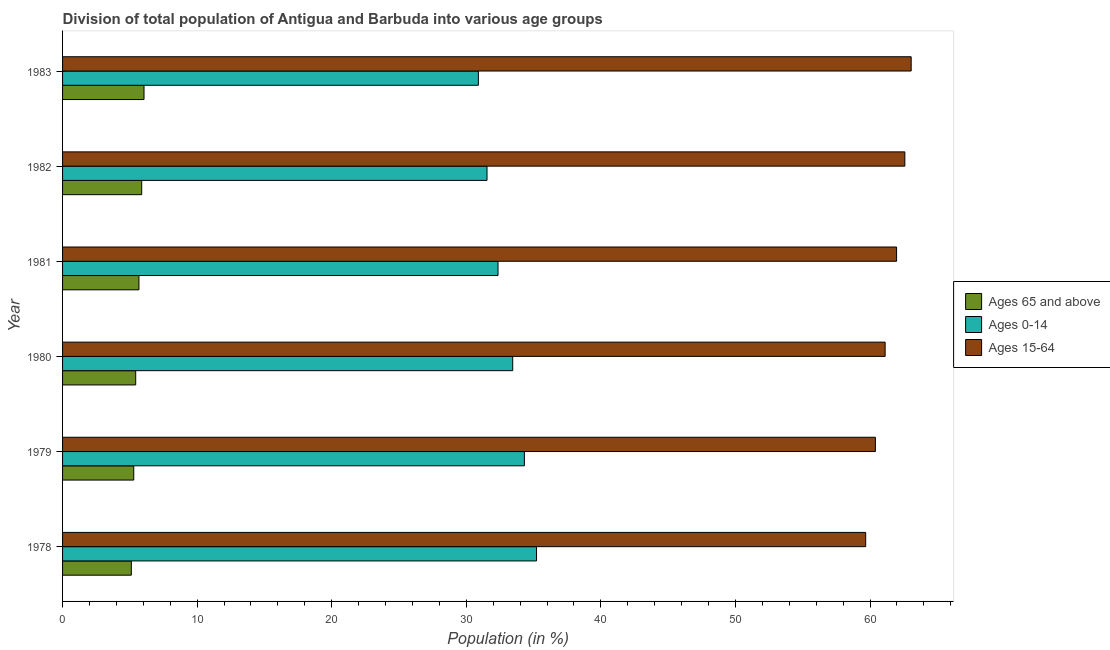How many groups of bars are there?
Provide a succinct answer. 6. Are the number of bars per tick equal to the number of legend labels?
Your response must be concise. Yes. How many bars are there on the 4th tick from the top?
Provide a short and direct response. 3. What is the label of the 1st group of bars from the top?
Keep it short and to the point. 1983. What is the percentage of population within the age-group of 65 and above in 1980?
Offer a very short reply. 5.43. Across all years, what is the maximum percentage of population within the age-group 0-14?
Your answer should be compact. 35.22. Across all years, what is the minimum percentage of population within the age-group of 65 and above?
Your response must be concise. 5.11. In which year was the percentage of population within the age-group 0-14 maximum?
Give a very brief answer. 1978. In which year was the percentage of population within the age-group of 65 and above minimum?
Provide a short and direct response. 1978. What is the total percentage of population within the age-group 0-14 in the graph?
Make the answer very short. 197.77. What is the difference between the percentage of population within the age-group 0-14 in 1979 and that in 1983?
Your answer should be compact. 3.42. What is the difference between the percentage of population within the age-group of 65 and above in 1983 and the percentage of population within the age-group 15-64 in 1982?
Offer a terse response. -56.53. What is the average percentage of population within the age-group 15-64 per year?
Keep it short and to the point. 61.47. In the year 1978, what is the difference between the percentage of population within the age-group 15-64 and percentage of population within the age-group of 65 and above?
Offer a terse response. 54.56. What is the ratio of the percentage of population within the age-group of 65 and above in 1978 to that in 1979?
Provide a succinct answer. 0.97. Is the percentage of population within the age-group of 65 and above in 1980 less than that in 1981?
Ensure brevity in your answer.  Yes. Is the difference between the percentage of population within the age-group 0-14 in 1978 and 1979 greater than the difference between the percentage of population within the age-group 15-64 in 1978 and 1979?
Provide a short and direct response. Yes. What is the difference between the highest and the second highest percentage of population within the age-group 0-14?
Provide a short and direct response. 0.9. What is the difference between the highest and the lowest percentage of population within the age-group 0-14?
Your answer should be compact. 4.32. In how many years, is the percentage of population within the age-group of 65 and above greater than the average percentage of population within the age-group of 65 and above taken over all years?
Provide a succinct answer. 3. What does the 3rd bar from the top in 1982 represents?
Provide a succinct answer. Ages 65 and above. What does the 3rd bar from the bottom in 1978 represents?
Your answer should be compact. Ages 15-64. Is it the case that in every year, the sum of the percentage of population within the age-group of 65 and above and percentage of population within the age-group 0-14 is greater than the percentage of population within the age-group 15-64?
Your response must be concise. No. How many bars are there?
Keep it short and to the point. 18. Are all the bars in the graph horizontal?
Provide a short and direct response. Yes. What is the difference between two consecutive major ticks on the X-axis?
Your answer should be very brief. 10. Are the values on the major ticks of X-axis written in scientific E-notation?
Offer a very short reply. No. Does the graph contain grids?
Keep it short and to the point. No. Where does the legend appear in the graph?
Provide a short and direct response. Center right. How many legend labels are there?
Your answer should be very brief. 3. How are the legend labels stacked?
Your answer should be compact. Vertical. What is the title of the graph?
Ensure brevity in your answer.  Division of total population of Antigua and Barbuda into various age groups
. What is the Population (in %) in Ages 65 and above in 1978?
Offer a terse response. 5.11. What is the Population (in %) in Ages 0-14 in 1978?
Provide a succinct answer. 35.22. What is the Population (in %) in Ages 15-64 in 1978?
Give a very brief answer. 59.67. What is the Population (in %) of Ages 65 and above in 1979?
Ensure brevity in your answer.  5.29. What is the Population (in %) in Ages 0-14 in 1979?
Provide a short and direct response. 34.31. What is the Population (in %) of Ages 15-64 in 1979?
Provide a succinct answer. 60.4. What is the Population (in %) of Ages 65 and above in 1980?
Make the answer very short. 5.43. What is the Population (in %) of Ages 0-14 in 1980?
Provide a short and direct response. 33.45. What is the Population (in %) in Ages 15-64 in 1980?
Offer a very short reply. 61.12. What is the Population (in %) of Ages 65 and above in 1981?
Offer a very short reply. 5.67. What is the Population (in %) in Ages 0-14 in 1981?
Your response must be concise. 32.36. What is the Population (in %) in Ages 15-64 in 1981?
Make the answer very short. 61.97. What is the Population (in %) in Ages 65 and above in 1982?
Your answer should be compact. 5.88. What is the Population (in %) in Ages 0-14 in 1982?
Make the answer very short. 31.54. What is the Population (in %) of Ages 15-64 in 1982?
Ensure brevity in your answer.  62.58. What is the Population (in %) in Ages 65 and above in 1983?
Offer a very short reply. 6.05. What is the Population (in %) in Ages 0-14 in 1983?
Make the answer very short. 30.89. What is the Population (in %) of Ages 15-64 in 1983?
Make the answer very short. 63.05. Across all years, what is the maximum Population (in %) in Ages 65 and above?
Your answer should be very brief. 6.05. Across all years, what is the maximum Population (in %) in Ages 0-14?
Your response must be concise. 35.22. Across all years, what is the maximum Population (in %) in Ages 15-64?
Make the answer very short. 63.05. Across all years, what is the minimum Population (in %) in Ages 65 and above?
Your answer should be very brief. 5.11. Across all years, what is the minimum Population (in %) of Ages 0-14?
Make the answer very short. 30.89. Across all years, what is the minimum Population (in %) of Ages 15-64?
Your response must be concise. 59.67. What is the total Population (in %) in Ages 65 and above in the graph?
Ensure brevity in your answer.  33.44. What is the total Population (in %) in Ages 0-14 in the graph?
Your answer should be compact. 197.77. What is the total Population (in %) in Ages 15-64 in the graph?
Offer a terse response. 368.8. What is the difference between the Population (in %) of Ages 65 and above in 1978 and that in 1979?
Ensure brevity in your answer.  -0.18. What is the difference between the Population (in %) in Ages 0-14 in 1978 and that in 1979?
Make the answer very short. 0.9. What is the difference between the Population (in %) of Ages 15-64 in 1978 and that in 1979?
Your answer should be very brief. -0.72. What is the difference between the Population (in %) in Ages 65 and above in 1978 and that in 1980?
Offer a very short reply. -0.33. What is the difference between the Population (in %) of Ages 0-14 in 1978 and that in 1980?
Ensure brevity in your answer.  1.77. What is the difference between the Population (in %) of Ages 15-64 in 1978 and that in 1980?
Keep it short and to the point. -1.44. What is the difference between the Population (in %) in Ages 65 and above in 1978 and that in 1981?
Your answer should be compact. -0.57. What is the difference between the Population (in %) in Ages 0-14 in 1978 and that in 1981?
Your answer should be compact. 2.86. What is the difference between the Population (in %) in Ages 15-64 in 1978 and that in 1981?
Provide a short and direct response. -2.3. What is the difference between the Population (in %) of Ages 65 and above in 1978 and that in 1982?
Make the answer very short. -0.77. What is the difference between the Population (in %) of Ages 0-14 in 1978 and that in 1982?
Keep it short and to the point. 3.68. What is the difference between the Population (in %) of Ages 15-64 in 1978 and that in 1982?
Your answer should be very brief. -2.91. What is the difference between the Population (in %) of Ages 65 and above in 1978 and that in 1983?
Offer a terse response. -0.94. What is the difference between the Population (in %) in Ages 0-14 in 1978 and that in 1983?
Your answer should be compact. 4.32. What is the difference between the Population (in %) in Ages 15-64 in 1978 and that in 1983?
Make the answer very short. -3.38. What is the difference between the Population (in %) of Ages 65 and above in 1979 and that in 1980?
Offer a terse response. -0.14. What is the difference between the Population (in %) in Ages 0-14 in 1979 and that in 1980?
Ensure brevity in your answer.  0.87. What is the difference between the Population (in %) of Ages 15-64 in 1979 and that in 1980?
Offer a very short reply. -0.72. What is the difference between the Population (in %) of Ages 65 and above in 1979 and that in 1981?
Make the answer very short. -0.38. What is the difference between the Population (in %) in Ages 0-14 in 1979 and that in 1981?
Your answer should be compact. 1.96. What is the difference between the Population (in %) in Ages 15-64 in 1979 and that in 1981?
Your response must be concise. -1.57. What is the difference between the Population (in %) in Ages 65 and above in 1979 and that in 1982?
Your answer should be compact. -0.59. What is the difference between the Population (in %) in Ages 0-14 in 1979 and that in 1982?
Offer a terse response. 2.78. What is the difference between the Population (in %) in Ages 15-64 in 1979 and that in 1982?
Give a very brief answer. -2.19. What is the difference between the Population (in %) of Ages 65 and above in 1979 and that in 1983?
Offer a terse response. -0.76. What is the difference between the Population (in %) in Ages 0-14 in 1979 and that in 1983?
Provide a short and direct response. 3.42. What is the difference between the Population (in %) of Ages 15-64 in 1979 and that in 1983?
Your answer should be very brief. -2.66. What is the difference between the Population (in %) in Ages 65 and above in 1980 and that in 1981?
Your response must be concise. -0.24. What is the difference between the Population (in %) of Ages 0-14 in 1980 and that in 1981?
Your answer should be compact. 1.09. What is the difference between the Population (in %) in Ages 15-64 in 1980 and that in 1981?
Your answer should be very brief. -0.85. What is the difference between the Population (in %) in Ages 65 and above in 1980 and that in 1982?
Your answer should be very brief. -0.45. What is the difference between the Population (in %) in Ages 0-14 in 1980 and that in 1982?
Make the answer very short. 1.91. What is the difference between the Population (in %) in Ages 15-64 in 1980 and that in 1982?
Provide a short and direct response. -1.46. What is the difference between the Population (in %) of Ages 65 and above in 1980 and that in 1983?
Your answer should be compact. -0.62. What is the difference between the Population (in %) of Ages 0-14 in 1980 and that in 1983?
Your response must be concise. 2.55. What is the difference between the Population (in %) in Ages 15-64 in 1980 and that in 1983?
Provide a short and direct response. -1.94. What is the difference between the Population (in %) in Ages 65 and above in 1981 and that in 1982?
Your answer should be compact. -0.21. What is the difference between the Population (in %) in Ages 0-14 in 1981 and that in 1982?
Offer a terse response. 0.82. What is the difference between the Population (in %) in Ages 15-64 in 1981 and that in 1982?
Provide a short and direct response. -0.61. What is the difference between the Population (in %) of Ages 65 and above in 1981 and that in 1983?
Keep it short and to the point. -0.38. What is the difference between the Population (in %) in Ages 0-14 in 1981 and that in 1983?
Offer a very short reply. 1.46. What is the difference between the Population (in %) in Ages 15-64 in 1981 and that in 1983?
Your answer should be very brief. -1.08. What is the difference between the Population (in %) of Ages 65 and above in 1982 and that in 1983?
Offer a very short reply. -0.17. What is the difference between the Population (in %) of Ages 0-14 in 1982 and that in 1983?
Your response must be concise. 0.64. What is the difference between the Population (in %) of Ages 15-64 in 1982 and that in 1983?
Your response must be concise. -0.47. What is the difference between the Population (in %) in Ages 65 and above in 1978 and the Population (in %) in Ages 0-14 in 1979?
Provide a succinct answer. -29.21. What is the difference between the Population (in %) in Ages 65 and above in 1978 and the Population (in %) in Ages 15-64 in 1979?
Offer a very short reply. -55.29. What is the difference between the Population (in %) of Ages 0-14 in 1978 and the Population (in %) of Ages 15-64 in 1979?
Give a very brief answer. -25.18. What is the difference between the Population (in %) of Ages 65 and above in 1978 and the Population (in %) of Ages 0-14 in 1980?
Give a very brief answer. -28.34. What is the difference between the Population (in %) of Ages 65 and above in 1978 and the Population (in %) of Ages 15-64 in 1980?
Ensure brevity in your answer.  -56.01. What is the difference between the Population (in %) of Ages 0-14 in 1978 and the Population (in %) of Ages 15-64 in 1980?
Provide a short and direct response. -25.9. What is the difference between the Population (in %) of Ages 65 and above in 1978 and the Population (in %) of Ages 0-14 in 1981?
Provide a succinct answer. -27.25. What is the difference between the Population (in %) in Ages 65 and above in 1978 and the Population (in %) in Ages 15-64 in 1981?
Provide a succinct answer. -56.86. What is the difference between the Population (in %) in Ages 0-14 in 1978 and the Population (in %) in Ages 15-64 in 1981?
Your response must be concise. -26.75. What is the difference between the Population (in %) in Ages 65 and above in 1978 and the Population (in %) in Ages 0-14 in 1982?
Your answer should be compact. -26.43. What is the difference between the Population (in %) of Ages 65 and above in 1978 and the Population (in %) of Ages 15-64 in 1982?
Provide a short and direct response. -57.47. What is the difference between the Population (in %) of Ages 0-14 in 1978 and the Population (in %) of Ages 15-64 in 1982?
Provide a succinct answer. -27.37. What is the difference between the Population (in %) in Ages 65 and above in 1978 and the Population (in %) in Ages 0-14 in 1983?
Your answer should be very brief. -25.79. What is the difference between the Population (in %) in Ages 65 and above in 1978 and the Population (in %) in Ages 15-64 in 1983?
Make the answer very short. -57.95. What is the difference between the Population (in %) of Ages 0-14 in 1978 and the Population (in %) of Ages 15-64 in 1983?
Make the answer very short. -27.84. What is the difference between the Population (in %) in Ages 65 and above in 1979 and the Population (in %) in Ages 0-14 in 1980?
Provide a short and direct response. -28.16. What is the difference between the Population (in %) of Ages 65 and above in 1979 and the Population (in %) of Ages 15-64 in 1980?
Provide a succinct answer. -55.83. What is the difference between the Population (in %) in Ages 0-14 in 1979 and the Population (in %) in Ages 15-64 in 1980?
Ensure brevity in your answer.  -26.8. What is the difference between the Population (in %) of Ages 65 and above in 1979 and the Population (in %) of Ages 0-14 in 1981?
Offer a terse response. -27.07. What is the difference between the Population (in %) in Ages 65 and above in 1979 and the Population (in %) in Ages 15-64 in 1981?
Your answer should be compact. -56.68. What is the difference between the Population (in %) of Ages 0-14 in 1979 and the Population (in %) of Ages 15-64 in 1981?
Give a very brief answer. -27.66. What is the difference between the Population (in %) in Ages 65 and above in 1979 and the Population (in %) in Ages 0-14 in 1982?
Provide a short and direct response. -26.25. What is the difference between the Population (in %) in Ages 65 and above in 1979 and the Population (in %) in Ages 15-64 in 1982?
Keep it short and to the point. -57.29. What is the difference between the Population (in %) in Ages 0-14 in 1979 and the Population (in %) in Ages 15-64 in 1982?
Provide a short and direct response. -28.27. What is the difference between the Population (in %) of Ages 65 and above in 1979 and the Population (in %) of Ages 0-14 in 1983?
Provide a short and direct response. -25.6. What is the difference between the Population (in %) of Ages 65 and above in 1979 and the Population (in %) of Ages 15-64 in 1983?
Offer a very short reply. -57.76. What is the difference between the Population (in %) in Ages 0-14 in 1979 and the Population (in %) in Ages 15-64 in 1983?
Provide a succinct answer. -28.74. What is the difference between the Population (in %) of Ages 65 and above in 1980 and the Population (in %) of Ages 0-14 in 1981?
Your response must be concise. -26.92. What is the difference between the Population (in %) of Ages 65 and above in 1980 and the Population (in %) of Ages 15-64 in 1981?
Give a very brief answer. -56.54. What is the difference between the Population (in %) of Ages 0-14 in 1980 and the Population (in %) of Ages 15-64 in 1981?
Provide a succinct answer. -28.52. What is the difference between the Population (in %) of Ages 65 and above in 1980 and the Population (in %) of Ages 0-14 in 1982?
Your answer should be compact. -26.1. What is the difference between the Population (in %) of Ages 65 and above in 1980 and the Population (in %) of Ages 15-64 in 1982?
Offer a very short reply. -57.15. What is the difference between the Population (in %) of Ages 0-14 in 1980 and the Population (in %) of Ages 15-64 in 1982?
Keep it short and to the point. -29.14. What is the difference between the Population (in %) in Ages 65 and above in 1980 and the Population (in %) in Ages 0-14 in 1983?
Make the answer very short. -25.46. What is the difference between the Population (in %) of Ages 65 and above in 1980 and the Population (in %) of Ages 15-64 in 1983?
Provide a succinct answer. -57.62. What is the difference between the Population (in %) in Ages 0-14 in 1980 and the Population (in %) in Ages 15-64 in 1983?
Make the answer very short. -29.61. What is the difference between the Population (in %) in Ages 65 and above in 1981 and the Population (in %) in Ages 0-14 in 1982?
Provide a short and direct response. -25.86. What is the difference between the Population (in %) of Ages 65 and above in 1981 and the Population (in %) of Ages 15-64 in 1982?
Provide a succinct answer. -56.91. What is the difference between the Population (in %) of Ages 0-14 in 1981 and the Population (in %) of Ages 15-64 in 1982?
Ensure brevity in your answer.  -30.23. What is the difference between the Population (in %) in Ages 65 and above in 1981 and the Population (in %) in Ages 0-14 in 1983?
Ensure brevity in your answer.  -25.22. What is the difference between the Population (in %) of Ages 65 and above in 1981 and the Population (in %) of Ages 15-64 in 1983?
Provide a succinct answer. -57.38. What is the difference between the Population (in %) in Ages 0-14 in 1981 and the Population (in %) in Ages 15-64 in 1983?
Keep it short and to the point. -30.7. What is the difference between the Population (in %) of Ages 65 and above in 1982 and the Population (in %) of Ages 0-14 in 1983?
Make the answer very short. -25.01. What is the difference between the Population (in %) of Ages 65 and above in 1982 and the Population (in %) of Ages 15-64 in 1983?
Your answer should be compact. -57.17. What is the difference between the Population (in %) in Ages 0-14 in 1982 and the Population (in %) in Ages 15-64 in 1983?
Keep it short and to the point. -31.52. What is the average Population (in %) of Ages 65 and above per year?
Keep it short and to the point. 5.57. What is the average Population (in %) of Ages 0-14 per year?
Offer a terse response. 32.96. What is the average Population (in %) of Ages 15-64 per year?
Your answer should be very brief. 61.47. In the year 1978, what is the difference between the Population (in %) of Ages 65 and above and Population (in %) of Ages 0-14?
Make the answer very short. -30.11. In the year 1978, what is the difference between the Population (in %) in Ages 65 and above and Population (in %) in Ages 15-64?
Your response must be concise. -54.57. In the year 1978, what is the difference between the Population (in %) of Ages 0-14 and Population (in %) of Ages 15-64?
Ensure brevity in your answer.  -24.46. In the year 1979, what is the difference between the Population (in %) of Ages 65 and above and Population (in %) of Ages 0-14?
Provide a short and direct response. -29.02. In the year 1979, what is the difference between the Population (in %) of Ages 65 and above and Population (in %) of Ages 15-64?
Your response must be concise. -55.11. In the year 1979, what is the difference between the Population (in %) in Ages 0-14 and Population (in %) in Ages 15-64?
Provide a succinct answer. -26.08. In the year 1980, what is the difference between the Population (in %) in Ages 65 and above and Population (in %) in Ages 0-14?
Make the answer very short. -28.01. In the year 1980, what is the difference between the Population (in %) in Ages 65 and above and Population (in %) in Ages 15-64?
Offer a very short reply. -55.68. In the year 1980, what is the difference between the Population (in %) in Ages 0-14 and Population (in %) in Ages 15-64?
Provide a succinct answer. -27.67. In the year 1981, what is the difference between the Population (in %) of Ages 65 and above and Population (in %) of Ages 0-14?
Your response must be concise. -26.68. In the year 1981, what is the difference between the Population (in %) in Ages 65 and above and Population (in %) in Ages 15-64?
Offer a very short reply. -56.3. In the year 1981, what is the difference between the Population (in %) of Ages 0-14 and Population (in %) of Ages 15-64?
Keep it short and to the point. -29.61. In the year 1982, what is the difference between the Population (in %) of Ages 65 and above and Population (in %) of Ages 0-14?
Provide a succinct answer. -25.66. In the year 1982, what is the difference between the Population (in %) in Ages 65 and above and Population (in %) in Ages 15-64?
Offer a very short reply. -56.7. In the year 1982, what is the difference between the Population (in %) in Ages 0-14 and Population (in %) in Ages 15-64?
Make the answer very short. -31.05. In the year 1983, what is the difference between the Population (in %) of Ages 65 and above and Population (in %) of Ages 0-14?
Ensure brevity in your answer.  -24.84. In the year 1983, what is the difference between the Population (in %) of Ages 65 and above and Population (in %) of Ages 15-64?
Your answer should be very brief. -57. In the year 1983, what is the difference between the Population (in %) of Ages 0-14 and Population (in %) of Ages 15-64?
Give a very brief answer. -32.16. What is the ratio of the Population (in %) of Ages 65 and above in 1978 to that in 1979?
Keep it short and to the point. 0.97. What is the ratio of the Population (in %) of Ages 0-14 in 1978 to that in 1979?
Make the answer very short. 1.03. What is the ratio of the Population (in %) in Ages 15-64 in 1978 to that in 1979?
Your response must be concise. 0.99. What is the ratio of the Population (in %) in Ages 65 and above in 1978 to that in 1980?
Your response must be concise. 0.94. What is the ratio of the Population (in %) of Ages 0-14 in 1978 to that in 1980?
Make the answer very short. 1.05. What is the ratio of the Population (in %) in Ages 15-64 in 1978 to that in 1980?
Provide a short and direct response. 0.98. What is the ratio of the Population (in %) of Ages 65 and above in 1978 to that in 1981?
Provide a short and direct response. 0.9. What is the ratio of the Population (in %) of Ages 0-14 in 1978 to that in 1981?
Your answer should be very brief. 1.09. What is the ratio of the Population (in %) of Ages 15-64 in 1978 to that in 1981?
Ensure brevity in your answer.  0.96. What is the ratio of the Population (in %) of Ages 65 and above in 1978 to that in 1982?
Keep it short and to the point. 0.87. What is the ratio of the Population (in %) in Ages 0-14 in 1978 to that in 1982?
Your answer should be compact. 1.12. What is the ratio of the Population (in %) in Ages 15-64 in 1978 to that in 1982?
Offer a very short reply. 0.95. What is the ratio of the Population (in %) of Ages 65 and above in 1978 to that in 1983?
Provide a short and direct response. 0.84. What is the ratio of the Population (in %) in Ages 0-14 in 1978 to that in 1983?
Provide a succinct answer. 1.14. What is the ratio of the Population (in %) in Ages 15-64 in 1978 to that in 1983?
Your answer should be very brief. 0.95. What is the ratio of the Population (in %) of Ages 65 and above in 1979 to that in 1980?
Give a very brief answer. 0.97. What is the ratio of the Population (in %) of Ages 0-14 in 1979 to that in 1980?
Offer a very short reply. 1.03. What is the ratio of the Population (in %) of Ages 15-64 in 1979 to that in 1980?
Give a very brief answer. 0.99. What is the ratio of the Population (in %) of Ages 65 and above in 1979 to that in 1981?
Your answer should be very brief. 0.93. What is the ratio of the Population (in %) in Ages 0-14 in 1979 to that in 1981?
Your response must be concise. 1.06. What is the ratio of the Population (in %) of Ages 15-64 in 1979 to that in 1981?
Make the answer very short. 0.97. What is the ratio of the Population (in %) of Ages 65 and above in 1979 to that in 1982?
Ensure brevity in your answer.  0.9. What is the ratio of the Population (in %) in Ages 0-14 in 1979 to that in 1982?
Your answer should be compact. 1.09. What is the ratio of the Population (in %) of Ages 65 and above in 1979 to that in 1983?
Your answer should be compact. 0.87. What is the ratio of the Population (in %) in Ages 0-14 in 1979 to that in 1983?
Your answer should be compact. 1.11. What is the ratio of the Population (in %) in Ages 15-64 in 1979 to that in 1983?
Provide a succinct answer. 0.96. What is the ratio of the Population (in %) of Ages 65 and above in 1980 to that in 1981?
Offer a very short reply. 0.96. What is the ratio of the Population (in %) of Ages 0-14 in 1980 to that in 1981?
Your answer should be very brief. 1.03. What is the ratio of the Population (in %) of Ages 15-64 in 1980 to that in 1981?
Provide a short and direct response. 0.99. What is the ratio of the Population (in %) of Ages 65 and above in 1980 to that in 1982?
Give a very brief answer. 0.92. What is the ratio of the Population (in %) of Ages 0-14 in 1980 to that in 1982?
Your response must be concise. 1.06. What is the ratio of the Population (in %) of Ages 15-64 in 1980 to that in 1982?
Provide a short and direct response. 0.98. What is the ratio of the Population (in %) in Ages 65 and above in 1980 to that in 1983?
Provide a succinct answer. 0.9. What is the ratio of the Population (in %) of Ages 0-14 in 1980 to that in 1983?
Offer a very short reply. 1.08. What is the ratio of the Population (in %) in Ages 15-64 in 1980 to that in 1983?
Ensure brevity in your answer.  0.97. What is the ratio of the Population (in %) of Ages 65 and above in 1981 to that in 1982?
Keep it short and to the point. 0.97. What is the ratio of the Population (in %) of Ages 0-14 in 1981 to that in 1982?
Offer a terse response. 1.03. What is the ratio of the Population (in %) in Ages 15-64 in 1981 to that in 1982?
Your answer should be very brief. 0.99. What is the ratio of the Population (in %) in Ages 65 and above in 1981 to that in 1983?
Offer a very short reply. 0.94. What is the ratio of the Population (in %) of Ages 0-14 in 1981 to that in 1983?
Offer a terse response. 1.05. What is the ratio of the Population (in %) of Ages 15-64 in 1981 to that in 1983?
Provide a succinct answer. 0.98. What is the ratio of the Population (in %) in Ages 65 and above in 1982 to that in 1983?
Keep it short and to the point. 0.97. What is the ratio of the Population (in %) of Ages 0-14 in 1982 to that in 1983?
Your response must be concise. 1.02. What is the ratio of the Population (in %) in Ages 15-64 in 1982 to that in 1983?
Ensure brevity in your answer.  0.99. What is the difference between the highest and the second highest Population (in %) in Ages 65 and above?
Keep it short and to the point. 0.17. What is the difference between the highest and the second highest Population (in %) in Ages 0-14?
Give a very brief answer. 0.9. What is the difference between the highest and the second highest Population (in %) in Ages 15-64?
Ensure brevity in your answer.  0.47. What is the difference between the highest and the lowest Population (in %) of Ages 65 and above?
Provide a short and direct response. 0.94. What is the difference between the highest and the lowest Population (in %) of Ages 0-14?
Provide a short and direct response. 4.32. What is the difference between the highest and the lowest Population (in %) of Ages 15-64?
Your answer should be compact. 3.38. 